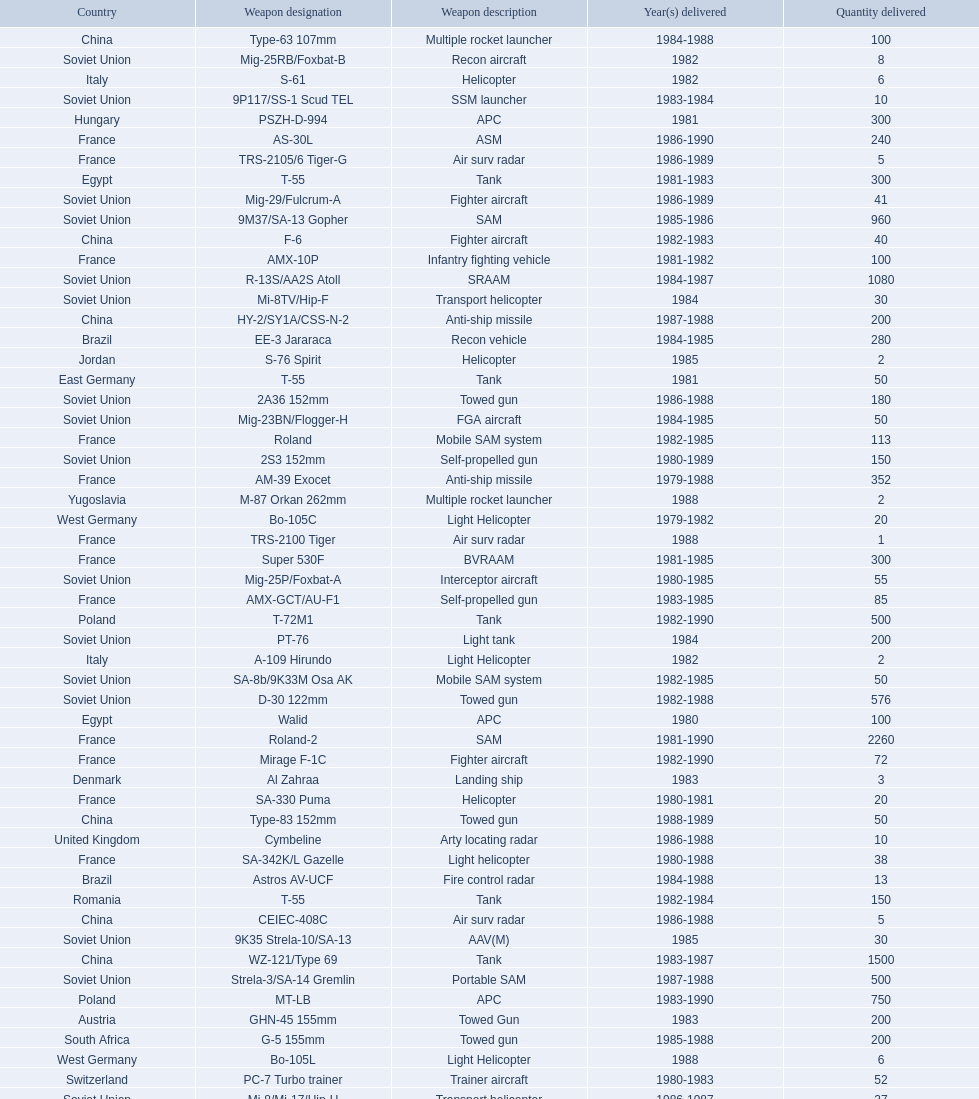Which country had the largest number of towed guns delivered? Soviet Union. 